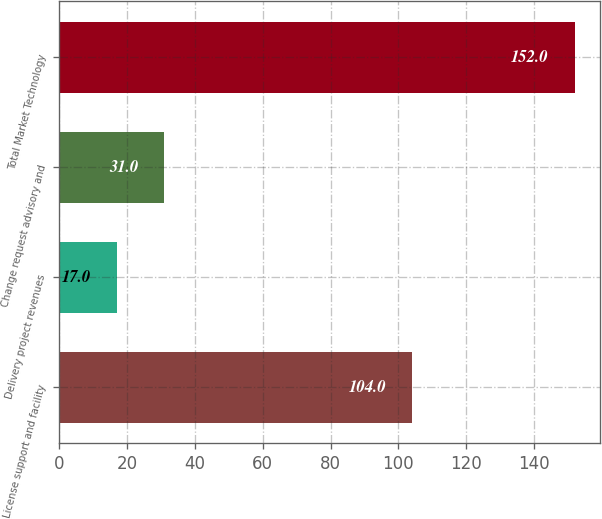Convert chart to OTSL. <chart><loc_0><loc_0><loc_500><loc_500><bar_chart><fcel>License support and facility<fcel>Delivery project revenues<fcel>Change request advisory and<fcel>Total Market Technology<nl><fcel>104<fcel>17<fcel>31<fcel>152<nl></chart> 